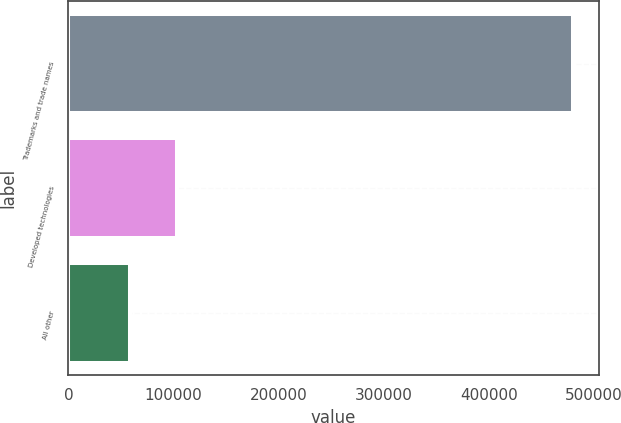Convert chart to OTSL. <chart><loc_0><loc_0><loc_500><loc_500><bar_chart><fcel>Trademarks and trade names<fcel>Developed technologies<fcel>All other<nl><fcel>480358<fcel>103351<fcel>58115<nl></chart> 